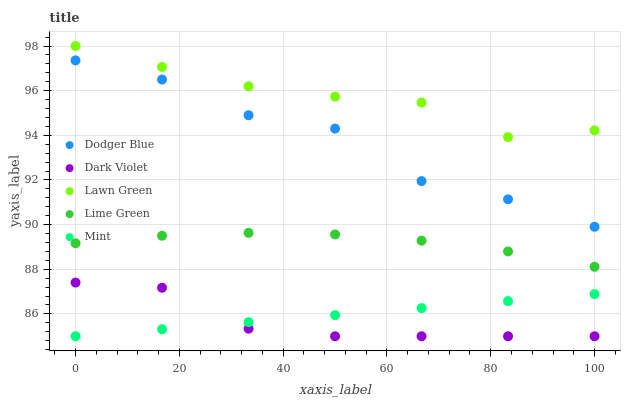Does Dark Violet have the minimum area under the curve?
Answer yes or no. Yes. Does Lawn Green have the maximum area under the curve?
Answer yes or no. Yes. Does Dodger Blue have the minimum area under the curve?
Answer yes or no. No. Does Dodger Blue have the maximum area under the curve?
Answer yes or no. No. Is Mint the smoothest?
Answer yes or no. Yes. Is Dodger Blue the roughest?
Answer yes or no. Yes. Is Lawn Green the smoothest?
Answer yes or no. No. Is Lawn Green the roughest?
Answer yes or no. No. Does Mint have the lowest value?
Answer yes or no. Yes. Does Dodger Blue have the lowest value?
Answer yes or no. No. Does Lawn Green have the highest value?
Answer yes or no. Yes. Does Dodger Blue have the highest value?
Answer yes or no. No. Is Dodger Blue less than Lawn Green?
Answer yes or no. Yes. Is Lawn Green greater than Lime Green?
Answer yes or no. Yes. Does Dark Violet intersect Mint?
Answer yes or no. Yes. Is Dark Violet less than Mint?
Answer yes or no. No. Is Dark Violet greater than Mint?
Answer yes or no. No. Does Dodger Blue intersect Lawn Green?
Answer yes or no. No. 